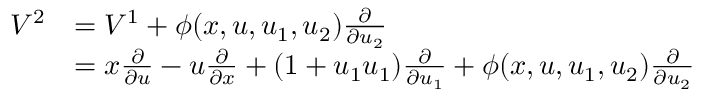Convert formula to latex. <formula><loc_0><loc_0><loc_500><loc_500>{ \begin{array} { r l } { V ^ { 2 } } & { = V ^ { 1 } + \phi ( x , u , u _ { 1 } , u _ { 2 } ) { \frac { \partial } { \partial u _ { 2 } } } } \\ & { = x { \frac { \partial } { \partial u } } - u { \frac { \partial } { \partial x } } + ( 1 + u _ { 1 } u _ { 1 } ) { \frac { \partial } { \partial u _ { 1 } } } + \phi ( x , u , u _ { 1 } , u _ { 2 } ) { \frac { \partial } { \partial u _ { 2 } } } } \end{array} }</formula> 